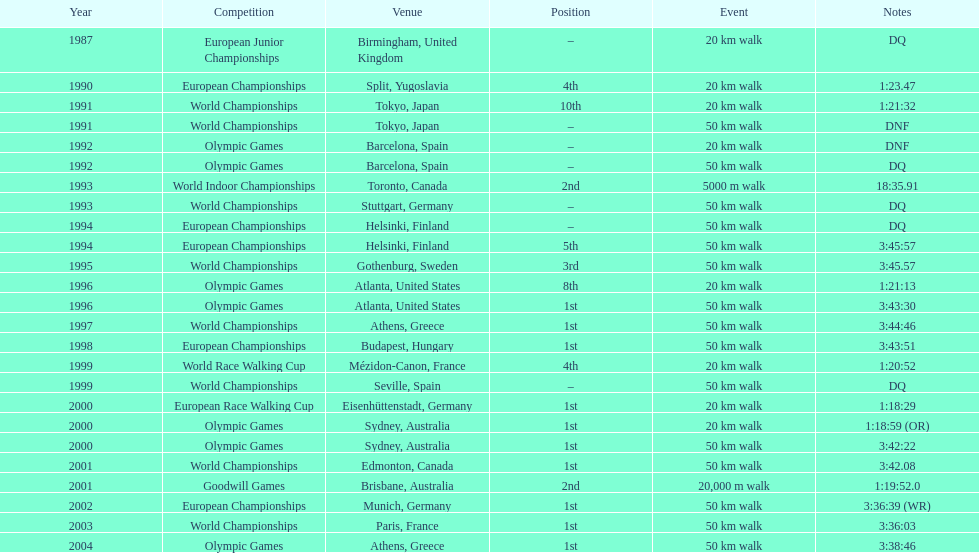How many times was first place listed as the position? 10. 